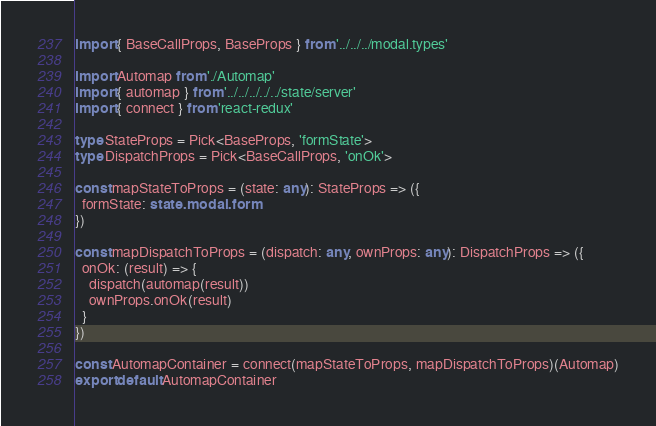Convert code to text. <code><loc_0><loc_0><loc_500><loc_500><_TypeScript_>
import { BaseCallProps, BaseProps } from '../../../modal.types'

import Automap from './Automap'
import { automap } from '../../../../../state/server'
import { connect } from 'react-redux'

type StateProps = Pick<BaseProps, 'formState'>
type DispatchProps = Pick<BaseCallProps, 'onOk'>

const mapStateToProps = (state: any): StateProps => ({
  formState: state.modal.form
})

const mapDispatchToProps = (dispatch: any, ownProps: any): DispatchProps => ({
  onOk: (result) => {
    dispatch(automap(result))
    ownProps.onOk(result)
  }
})

const AutomapContainer = connect(mapStateToProps, mapDispatchToProps)(Automap)
export default AutomapContainer
</code> 